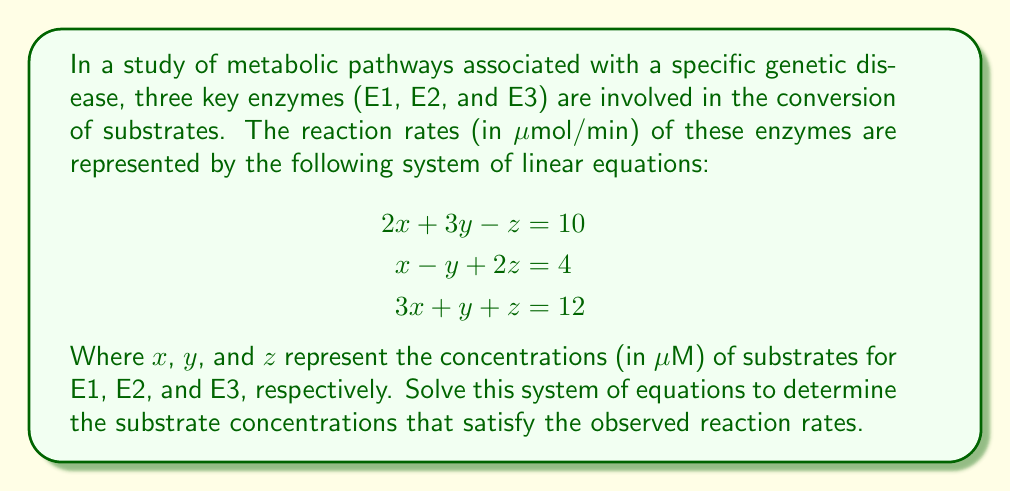Provide a solution to this math problem. To solve this system of linear equations, we'll use the Gaussian elimination method:

Step 1: Write the augmented matrix
$$
\begin{bmatrix}
2 & 3 & -1 & 10 \\
1 & -1 & 2 & 4 \\
3 & 1 & 1 & 12
\end{bmatrix}
$$

Step 2: Use row operations to transform the matrix into row echelon form

a) Multiply R1 by -1/2 and add to R2:
$$
\begin{bmatrix}
2 & 3 & -1 & 10 \\
0 & -5/2 & 5/2 & -1 \\
3 & 1 & 1 & 12
\end{bmatrix}
$$

b) Multiply R1 by -3/2 and add to R3:
$$
\begin{bmatrix}
2 & 3 & -1 & 10 \\
0 & -5/2 & 5/2 & -1 \\
0 & -7/2 & 5/2 & -3
\end{bmatrix}
$$

Step 3: Continue row operations to achieve reduced row echelon form

a) Multiply R2 by 2/5 to simplify:
$$
\begin{bmatrix}
2 & 3 & -1 & 10 \\
0 & 1 & -1 & 2/5 \\
0 & -7/2 & 5/2 & -3
\end{bmatrix}
$$

b) Multiply R2 by 7/2 and add to R3:
$$
\begin{bmatrix}
2 & 3 & -1 & 10 \\
0 & 1 & -1 & 2/5 \\
0 & 0 & 1 & -2/5
\end{bmatrix}
$$

c) Add R3 to R2:
$$
\begin{bmatrix}
2 & 3 & -1 & 10 \\
0 & 1 & 0 & 4/5 \\
0 & 0 & 1 & -2/5
\end{bmatrix}
$$

d) Add R3 to R1, then subtract 3R2 from R1:
$$
\begin{bmatrix}
2 & 0 & 0 & 8 \\
0 & 1 & 0 & 4/5 \\
0 & 0 & 1 & -2/5
\end{bmatrix}
$$

Step 4: Read off the solution
From the final matrix, we can read:
$2x = 8$, so $x = 4$
$y = 4/5$
$z = -2/5$

Therefore, the concentrations of substrates are:
$x = 4$ μM
$y = 0.8$ μM
$z = -0.4$ μM (The negative value might indicate consumption rather than production in this pathway)
Answer: $x = 4$ μM, $y = 0.8$ μM, $z = -0.4$ μM 